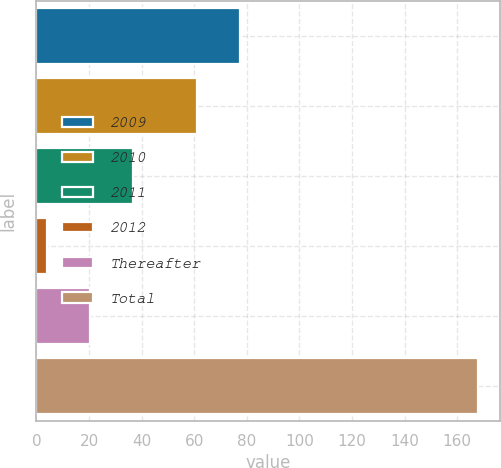Convert chart to OTSL. <chart><loc_0><loc_0><loc_500><loc_500><bar_chart><fcel>2009<fcel>2010<fcel>2011<fcel>2012<fcel>Thereafter<fcel>Total<nl><fcel>77.4<fcel>61<fcel>36.8<fcel>4<fcel>20.4<fcel>168<nl></chart> 